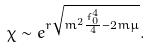<formula> <loc_0><loc_0><loc_500><loc_500>\chi \sim e ^ { r \sqrt { m ^ { 2 } \frac { f _ { 0 } ^ { 4 } } { 4 } - 2 m \mu } } .</formula> 